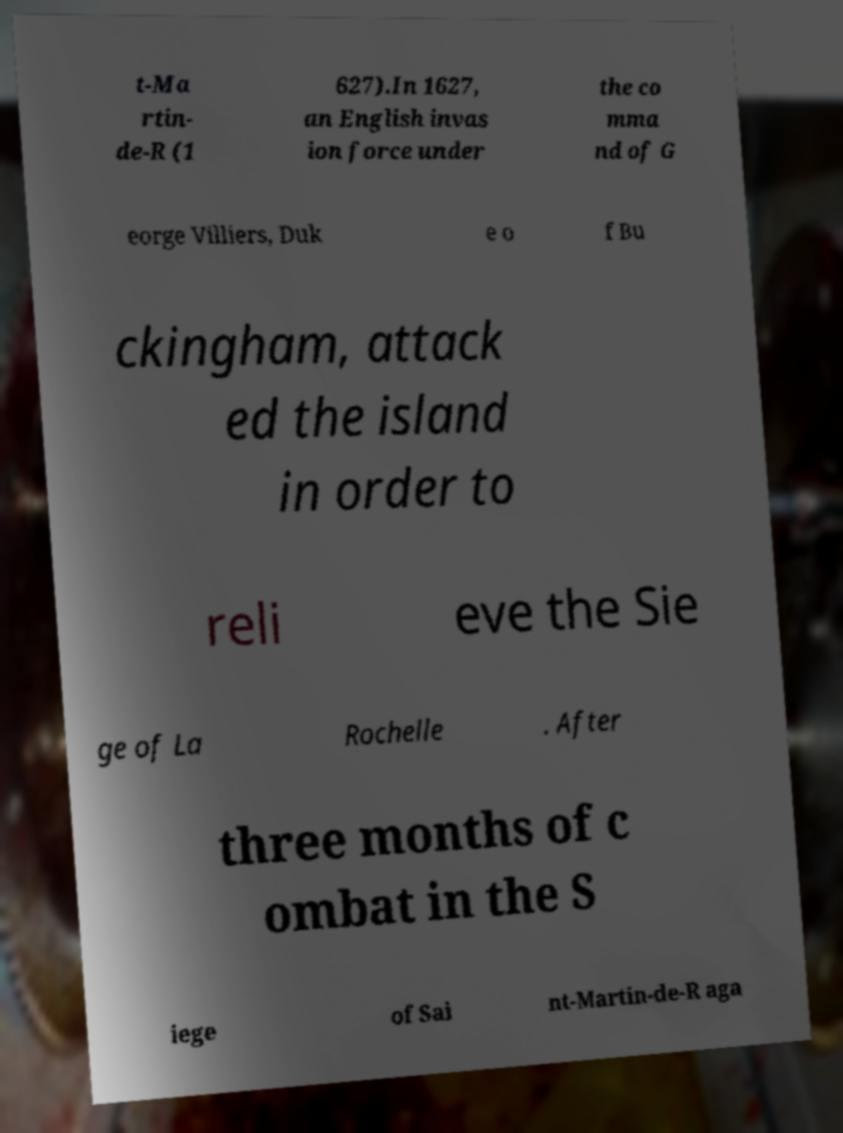Could you assist in decoding the text presented in this image and type it out clearly? t-Ma rtin- de-R (1 627).In 1627, an English invas ion force under the co mma nd of G eorge Villiers, Duk e o f Bu ckingham, attack ed the island in order to reli eve the Sie ge of La Rochelle . After three months of c ombat in the S iege of Sai nt-Martin-de-R aga 